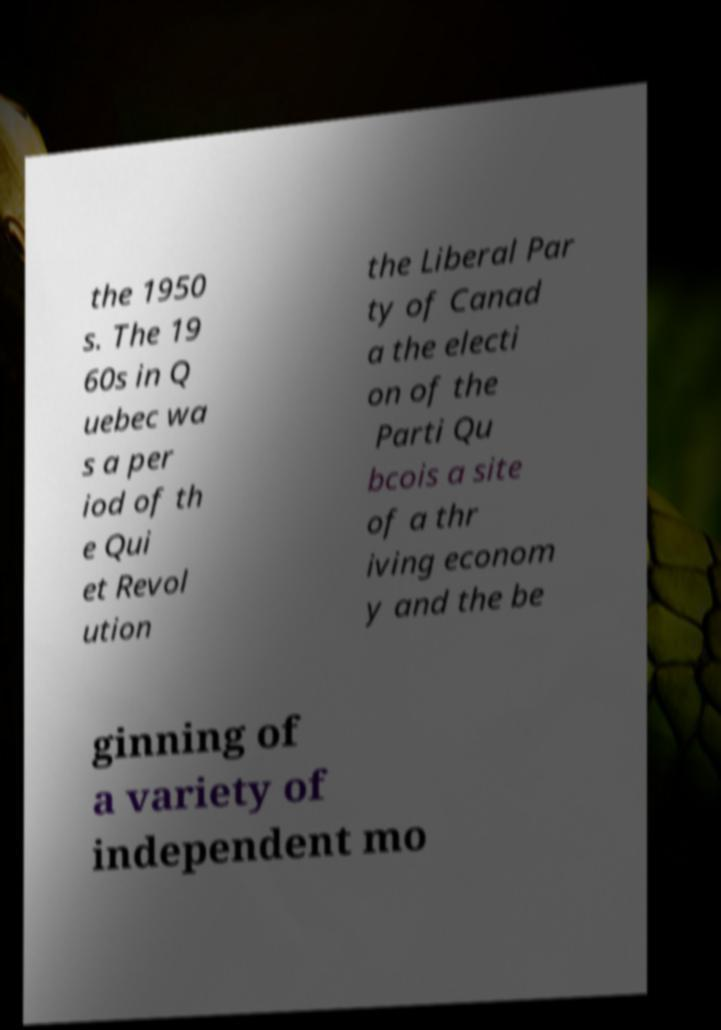I need the written content from this picture converted into text. Can you do that? the 1950 s. The 19 60s in Q uebec wa s a per iod of th e Qui et Revol ution the Liberal Par ty of Canad a the electi on of the Parti Qu bcois a site of a thr iving econom y and the be ginning of a variety of independent mo 